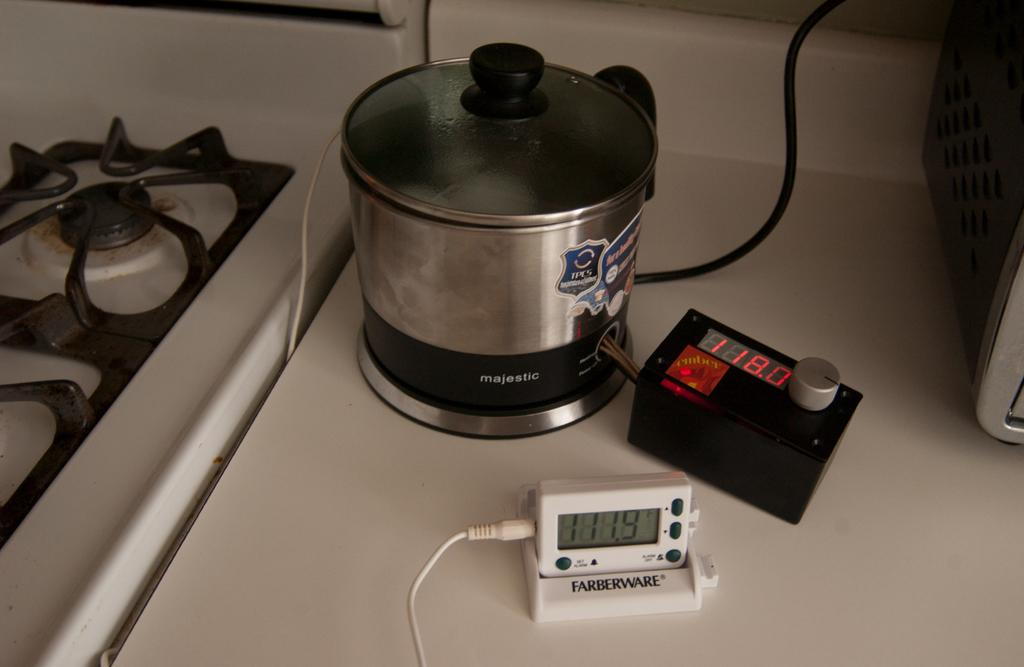Provide a one-sentence caption for the provided image. A Farberware kitchen timer sits on a counter next to a pot and another timer. 